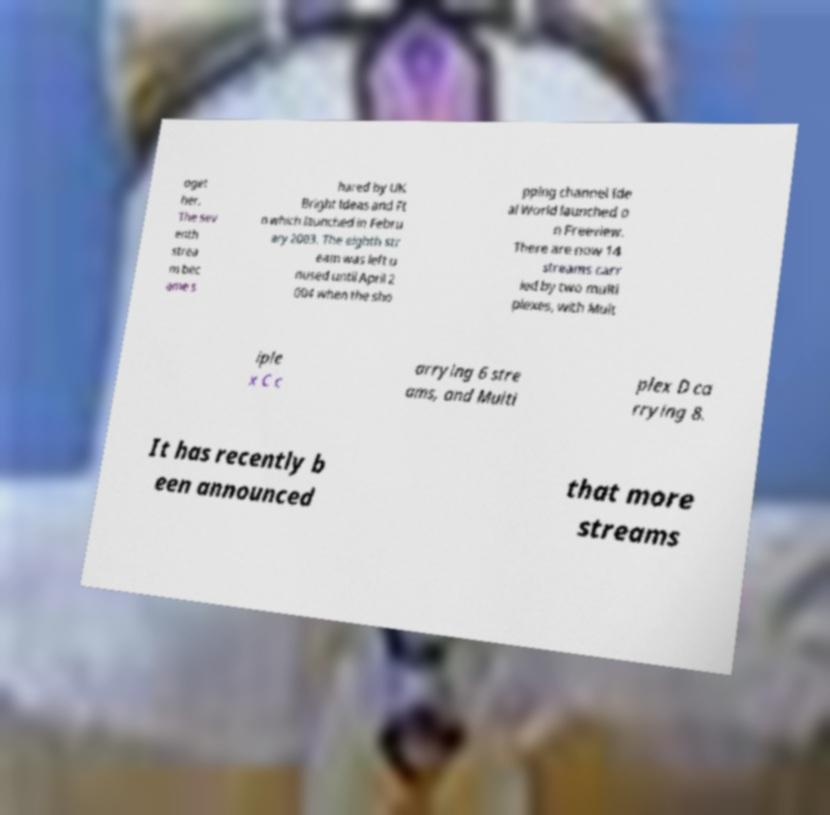Please read and relay the text visible in this image. What does it say? oget her. The sev enth strea m bec ame s hared by UK Bright Ideas and Ft n which launched in Febru ary 2003. The eighth str eam was left u nused until April 2 004 when the sho pping channel Ide al World launched o n Freeview. There are now 14 streams carr ied by two multi plexes, with Mult iple x C c arrying 6 stre ams, and Multi plex D ca rrying 8. It has recently b een announced that more streams 